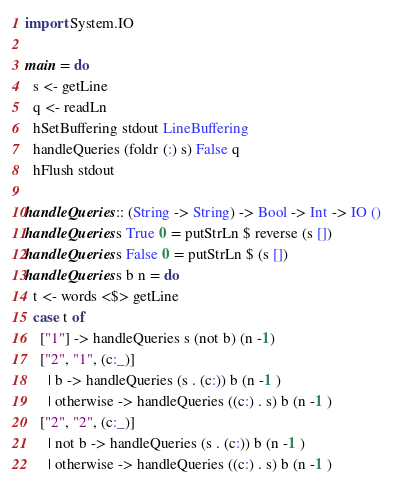<code> <loc_0><loc_0><loc_500><loc_500><_Haskell_>import System.IO

main = do
  s <- getLine
  q <- readLn
  hSetBuffering stdout LineBuffering 
  handleQueries (foldr (:) s) False q
  hFlush stdout

handleQueries :: (String -> String) -> Bool -> Int -> IO ()
handleQueries s True 0 = putStrLn $ reverse (s [])
handleQueries s False 0 = putStrLn $ (s [])
handleQueries s b n = do
  t <- words <$> getLine
  case t of
    ["1"] -> handleQueries s (not b) (n -1)
    ["2", "1", (c:_)]
      | b -> handleQueries (s . (c:)) b (n -1 )
      | otherwise -> handleQueries ((c:) . s) b (n -1 )
    ["2", "2", (c:_)]
      | not b -> handleQueries (s . (c:)) b (n -1 )
      | otherwise -> handleQueries ((c:) . s) b (n -1 )
</code> 